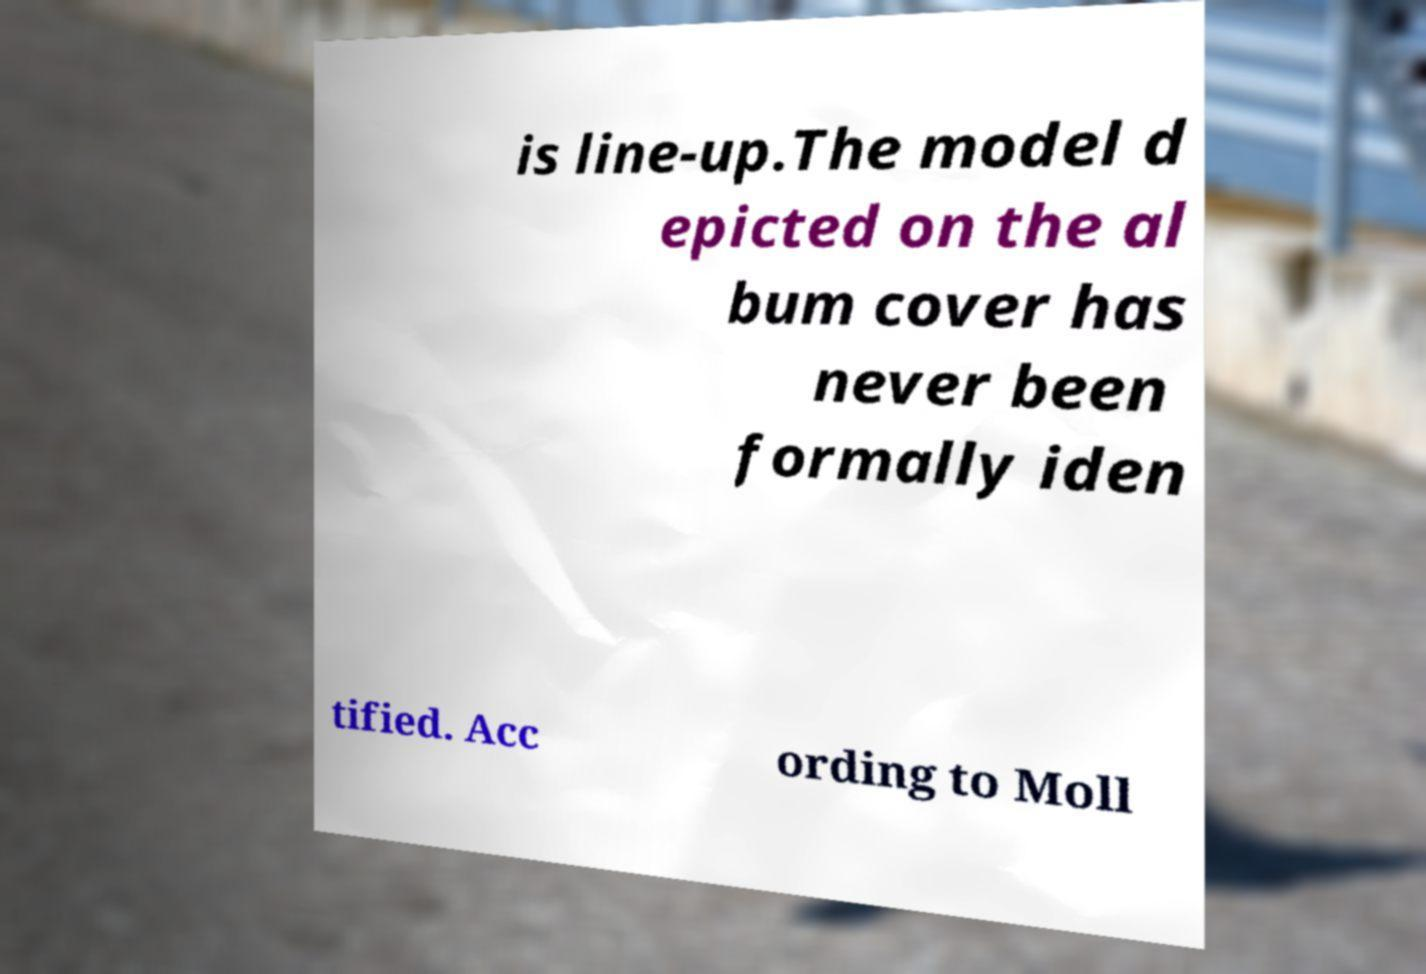What messages or text are displayed in this image? I need them in a readable, typed format. is line-up.The model d epicted on the al bum cover has never been formally iden tified. Acc ording to Moll 